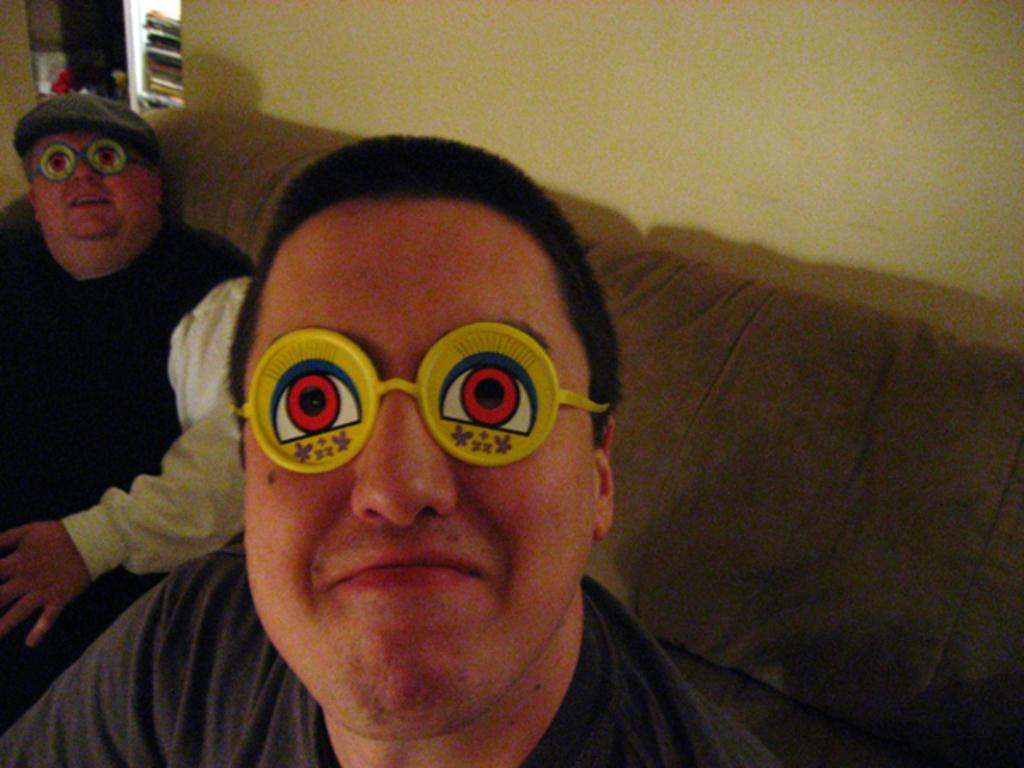What are the people in the image doing? The people in the image are sitting on a sofa. What are the people wearing on their faces? The people are wearing plastic toy goggles. What can be seen behind the people in the image? There is a wall visible in the image. What type of cherry is being used as a decoration on the sofa? There is no cherry present in the image, and therefore no such decoration can be observed. 